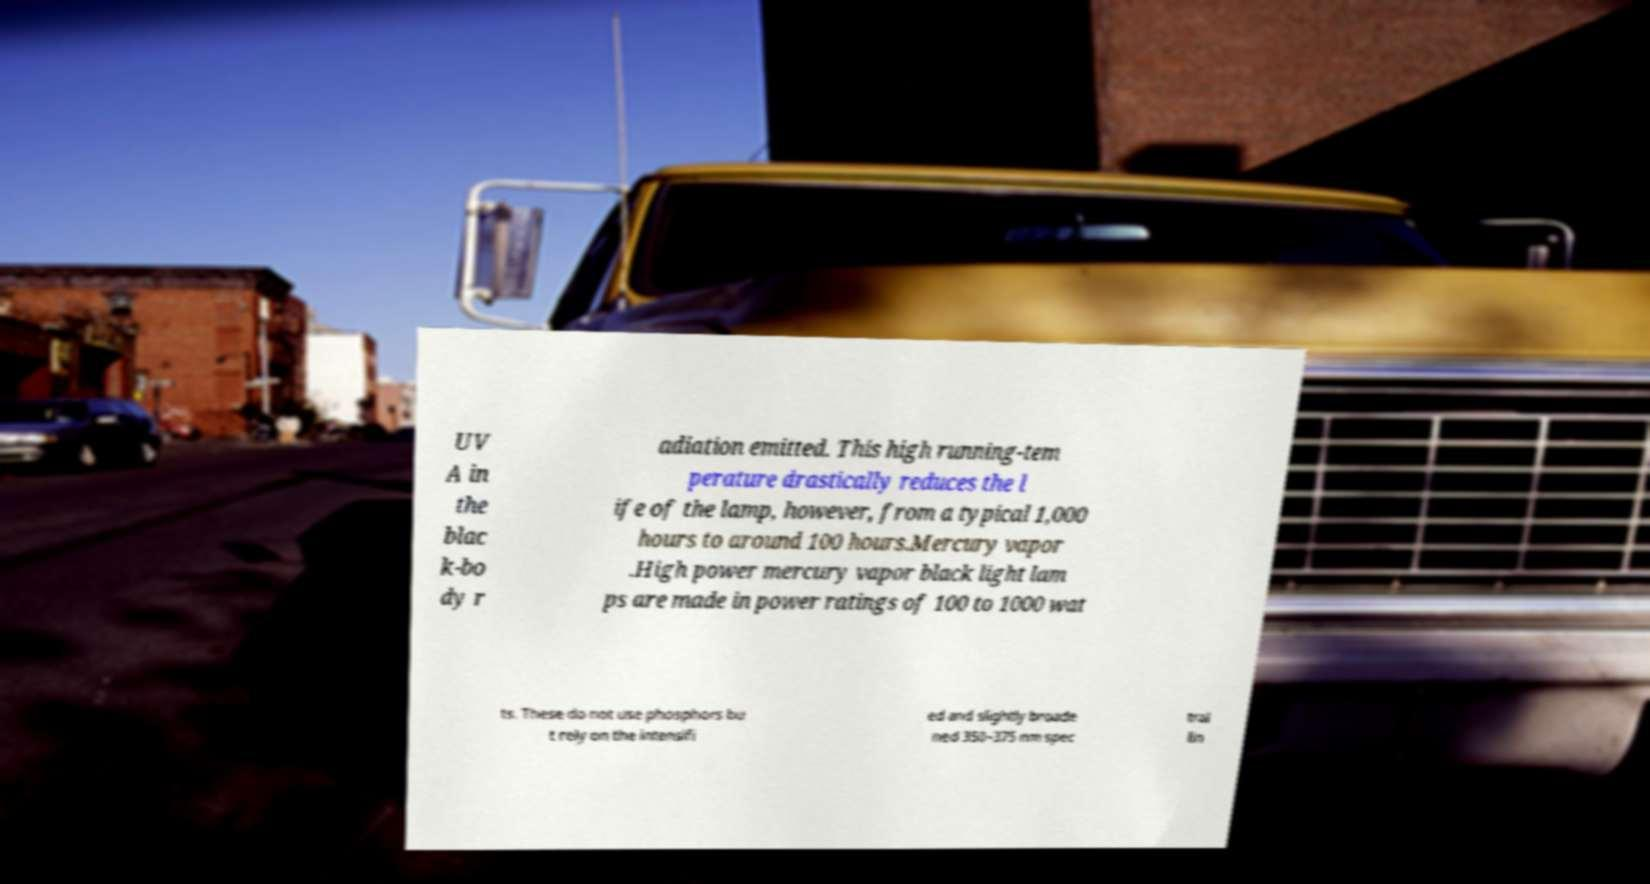Could you assist in decoding the text presented in this image and type it out clearly? UV A in the blac k-bo dy r adiation emitted. This high running-tem perature drastically reduces the l ife of the lamp, however, from a typical 1,000 hours to around 100 hours.Mercury vapor .High power mercury vapor black light lam ps are made in power ratings of 100 to 1000 wat ts. These do not use phosphors bu t rely on the intensifi ed and slightly broade ned 350–375 nm spec tral lin 